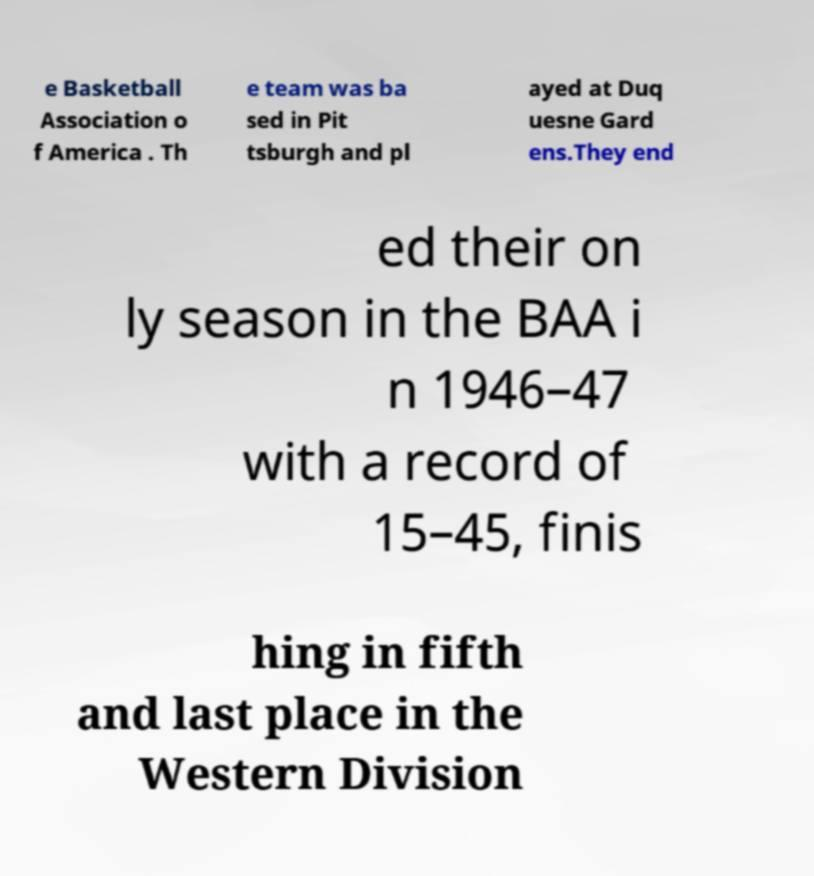Can you read and provide the text displayed in the image?This photo seems to have some interesting text. Can you extract and type it out for me? e Basketball Association o f America . Th e team was ba sed in Pit tsburgh and pl ayed at Duq uesne Gard ens.They end ed their on ly season in the BAA i n 1946–47 with a record of 15–45, finis hing in fifth and last place in the Western Division 